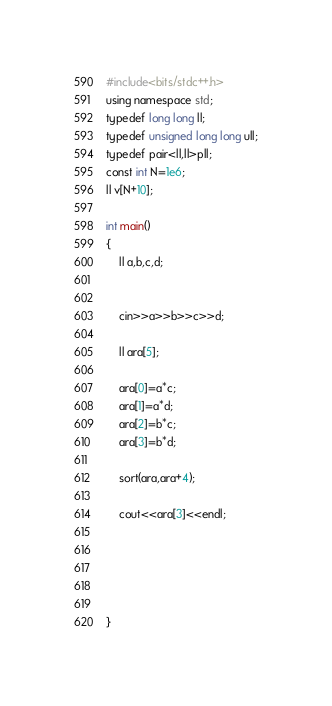Convert code to text. <code><loc_0><loc_0><loc_500><loc_500><_C++_>#include<bits/stdc++.h>
using namespace std;
typedef long long ll;
typedef unsigned long long ull;
typedef pair<ll,ll>pll;
const int N=1e6;
ll v[N+10];

int main()
{
    ll a,b,c,d;


    cin>>a>>b>>c>>d;

    ll ara[5];

    ara[0]=a*c;
    ara[1]=a*d;
    ara[2]=b*c;
    ara[3]=b*d;

    sort(ara,ara+4);

    cout<<ara[3]<<endl;





}
</code> 